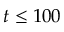<formula> <loc_0><loc_0><loc_500><loc_500>t \leq 1 0 0</formula> 